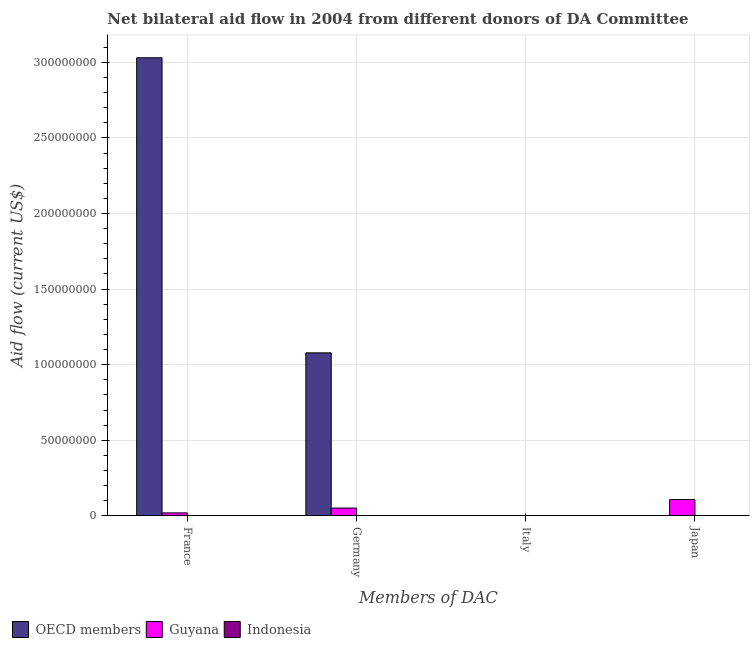How many different coloured bars are there?
Make the answer very short. 2. Across all countries, what is the maximum amount of aid given by france?
Offer a terse response. 3.03e+08. In which country was the amount of aid given by japan maximum?
Ensure brevity in your answer.  Guyana. What is the total amount of aid given by italy in the graph?
Make the answer very short. 2.00e+04. What is the difference between the amount of aid given by italy in Guyana and the amount of aid given by france in OECD members?
Give a very brief answer. -3.03e+08. What is the average amount of aid given by france per country?
Keep it short and to the point. 1.02e+08. What is the difference between the amount of aid given by france and amount of aid given by germany in Guyana?
Make the answer very short. -3.20e+06. What is the ratio of the amount of aid given by germany in Guyana to that in OECD members?
Provide a succinct answer. 0.05. Is the amount of aid given by germany in Guyana less than that in OECD members?
Your answer should be very brief. Yes. Is the difference between the amount of aid given by germany in OECD members and Guyana greater than the difference between the amount of aid given by france in OECD members and Guyana?
Your answer should be very brief. No. What is the difference between the highest and the lowest amount of aid given by japan?
Your answer should be very brief. 1.07e+07. In how many countries, is the amount of aid given by italy greater than the average amount of aid given by italy taken over all countries?
Provide a succinct answer. 1. What is the difference between two consecutive major ticks on the Y-axis?
Your answer should be compact. 5.00e+07. Does the graph contain any zero values?
Provide a short and direct response. Yes. Does the graph contain grids?
Provide a succinct answer. Yes. Where does the legend appear in the graph?
Your answer should be very brief. Bottom left. How are the legend labels stacked?
Give a very brief answer. Horizontal. What is the title of the graph?
Provide a short and direct response. Net bilateral aid flow in 2004 from different donors of DA Committee. Does "European Union" appear as one of the legend labels in the graph?
Make the answer very short. No. What is the label or title of the X-axis?
Your response must be concise. Members of DAC. What is the Aid flow (current US$) of OECD members in France?
Keep it short and to the point. 3.03e+08. What is the Aid flow (current US$) in Guyana in France?
Provide a short and direct response. 1.92e+06. What is the Aid flow (current US$) of OECD members in Germany?
Offer a terse response. 1.08e+08. What is the Aid flow (current US$) of Guyana in Germany?
Keep it short and to the point. 5.12e+06. What is the Aid flow (current US$) in Indonesia in Germany?
Ensure brevity in your answer.  0. What is the Aid flow (current US$) in OECD members in Italy?
Ensure brevity in your answer.  0. What is the Aid flow (current US$) of Indonesia in Italy?
Ensure brevity in your answer.  0. What is the Aid flow (current US$) of Guyana in Japan?
Provide a succinct answer. 1.07e+07. Across all Members of DAC, what is the maximum Aid flow (current US$) of OECD members?
Your response must be concise. 3.03e+08. Across all Members of DAC, what is the maximum Aid flow (current US$) of Guyana?
Ensure brevity in your answer.  1.07e+07. Across all Members of DAC, what is the minimum Aid flow (current US$) of OECD members?
Provide a short and direct response. 0. What is the total Aid flow (current US$) of OECD members in the graph?
Give a very brief answer. 4.11e+08. What is the total Aid flow (current US$) in Guyana in the graph?
Your response must be concise. 1.78e+07. What is the total Aid flow (current US$) in Indonesia in the graph?
Give a very brief answer. 0. What is the difference between the Aid flow (current US$) in OECD members in France and that in Germany?
Offer a terse response. 1.95e+08. What is the difference between the Aid flow (current US$) in Guyana in France and that in Germany?
Offer a very short reply. -3.20e+06. What is the difference between the Aid flow (current US$) in Guyana in France and that in Italy?
Your answer should be very brief. 1.90e+06. What is the difference between the Aid flow (current US$) of Guyana in France and that in Japan?
Keep it short and to the point. -8.80e+06. What is the difference between the Aid flow (current US$) in Guyana in Germany and that in Italy?
Offer a very short reply. 5.10e+06. What is the difference between the Aid flow (current US$) in Guyana in Germany and that in Japan?
Offer a very short reply. -5.60e+06. What is the difference between the Aid flow (current US$) of Guyana in Italy and that in Japan?
Provide a short and direct response. -1.07e+07. What is the difference between the Aid flow (current US$) of OECD members in France and the Aid flow (current US$) of Guyana in Germany?
Provide a short and direct response. 2.98e+08. What is the difference between the Aid flow (current US$) of OECD members in France and the Aid flow (current US$) of Guyana in Italy?
Offer a terse response. 3.03e+08. What is the difference between the Aid flow (current US$) of OECD members in France and the Aid flow (current US$) of Guyana in Japan?
Ensure brevity in your answer.  2.92e+08. What is the difference between the Aid flow (current US$) of OECD members in Germany and the Aid flow (current US$) of Guyana in Italy?
Keep it short and to the point. 1.08e+08. What is the difference between the Aid flow (current US$) of OECD members in Germany and the Aid flow (current US$) of Guyana in Japan?
Ensure brevity in your answer.  9.71e+07. What is the average Aid flow (current US$) in OECD members per Members of DAC?
Offer a terse response. 1.03e+08. What is the average Aid flow (current US$) of Guyana per Members of DAC?
Provide a succinct answer. 4.44e+06. What is the difference between the Aid flow (current US$) of OECD members and Aid flow (current US$) of Guyana in France?
Give a very brief answer. 3.01e+08. What is the difference between the Aid flow (current US$) of OECD members and Aid flow (current US$) of Guyana in Germany?
Keep it short and to the point. 1.03e+08. What is the ratio of the Aid flow (current US$) of OECD members in France to that in Germany?
Your answer should be very brief. 2.81. What is the ratio of the Aid flow (current US$) of Guyana in France to that in Italy?
Your answer should be compact. 96. What is the ratio of the Aid flow (current US$) of Guyana in France to that in Japan?
Your response must be concise. 0.18. What is the ratio of the Aid flow (current US$) of Guyana in Germany to that in Italy?
Offer a very short reply. 256. What is the ratio of the Aid flow (current US$) of Guyana in Germany to that in Japan?
Provide a short and direct response. 0.48. What is the ratio of the Aid flow (current US$) in Guyana in Italy to that in Japan?
Offer a terse response. 0. What is the difference between the highest and the second highest Aid flow (current US$) in Guyana?
Your answer should be very brief. 5.60e+06. What is the difference between the highest and the lowest Aid flow (current US$) in OECD members?
Your answer should be compact. 3.03e+08. What is the difference between the highest and the lowest Aid flow (current US$) of Guyana?
Provide a succinct answer. 1.07e+07. 